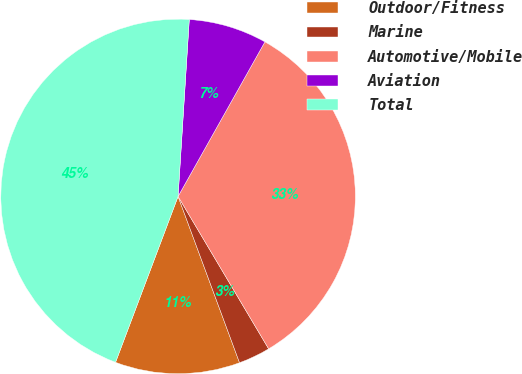Convert chart. <chart><loc_0><loc_0><loc_500><loc_500><pie_chart><fcel>Outdoor/Fitness<fcel>Marine<fcel>Automotive/Mobile<fcel>Aviation<fcel>Total<nl><fcel>11.37%<fcel>2.9%<fcel>33.32%<fcel>7.14%<fcel>45.27%<nl></chart> 